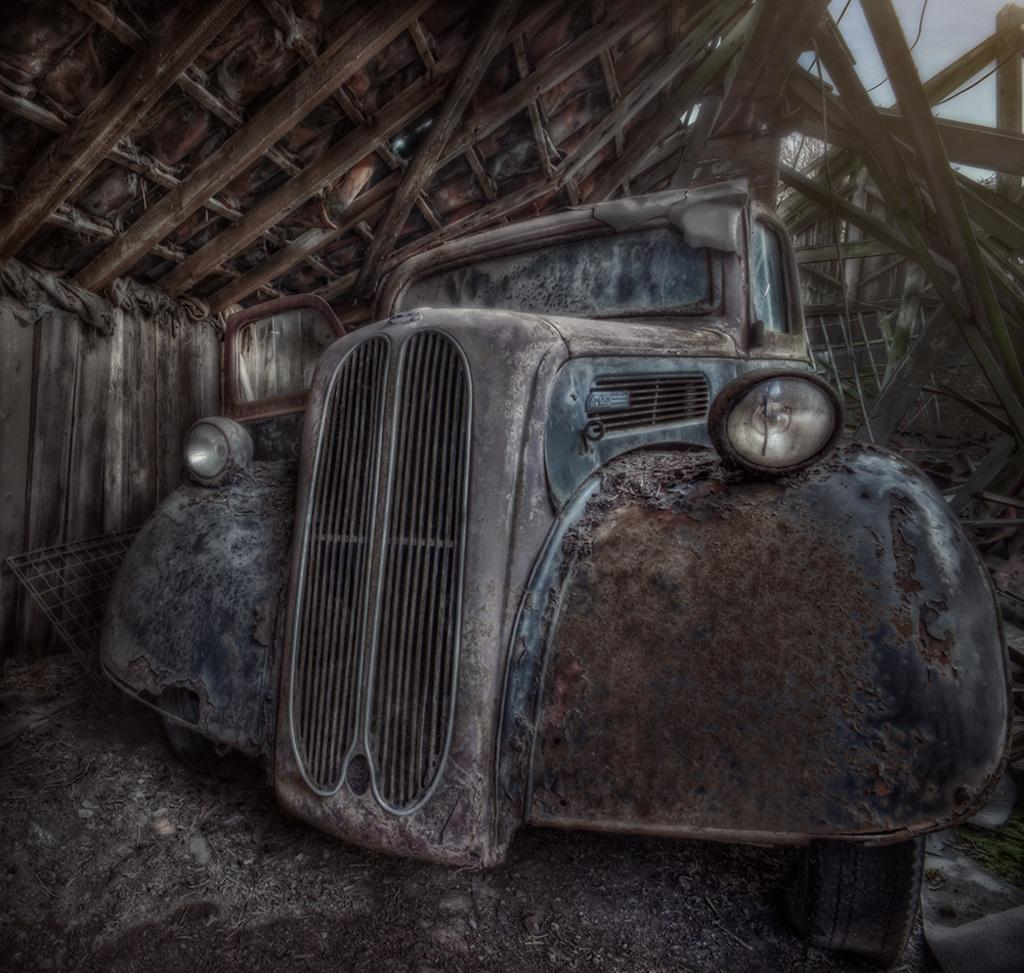What type of image is being described? The image is an animated image. What can be seen in the animated image? There is an old car in the image. Where is the old car located in the image? The old car is placed under a shed. How many eggs are visible on the old car in the image? There are no eggs visible on the old car in the image. What type of cloud can be seen in the image? There is no cloud present in the image, as it is an animated image of an old car under a shed. 